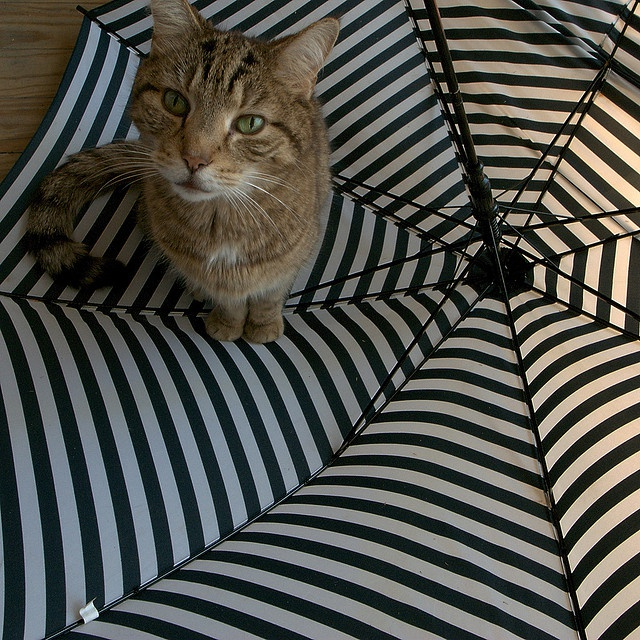Describe the objects in this image and their specific colors. I can see umbrella in black, darkgray, and gray tones and cat in gray and black tones in this image. 